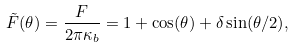<formula> <loc_0><loc_0><loc_500><loc_500>\tilde { F } ( \theta ) = \frac { F } { 2 \pi \kappa _ { b } } = 1 + \cos ( \theta ) + \delta \sin ( \theta / 2 ) ,</formula> 